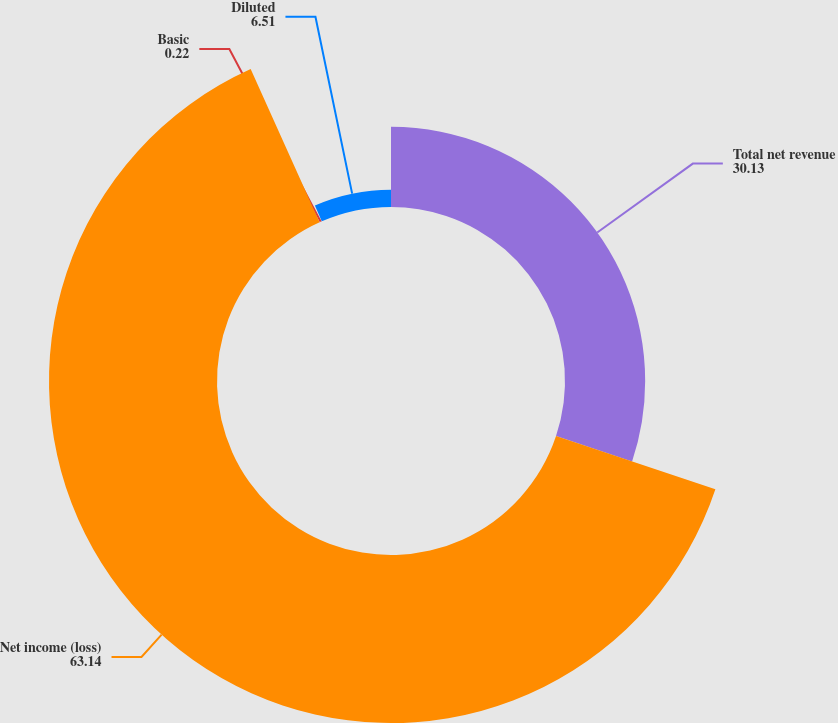Convert chart to OTSL. <chart><loc_0><loc_0><loc_500><loc_500><pie_chart><fcel>Total net revenue<fcel>Net income (loss)<fcel>Basic<fcel>Diluted<nl><fcel>30.13%<fcel>63.14%<fcel>0.22%<fcel>6.51%<nl></chart> 